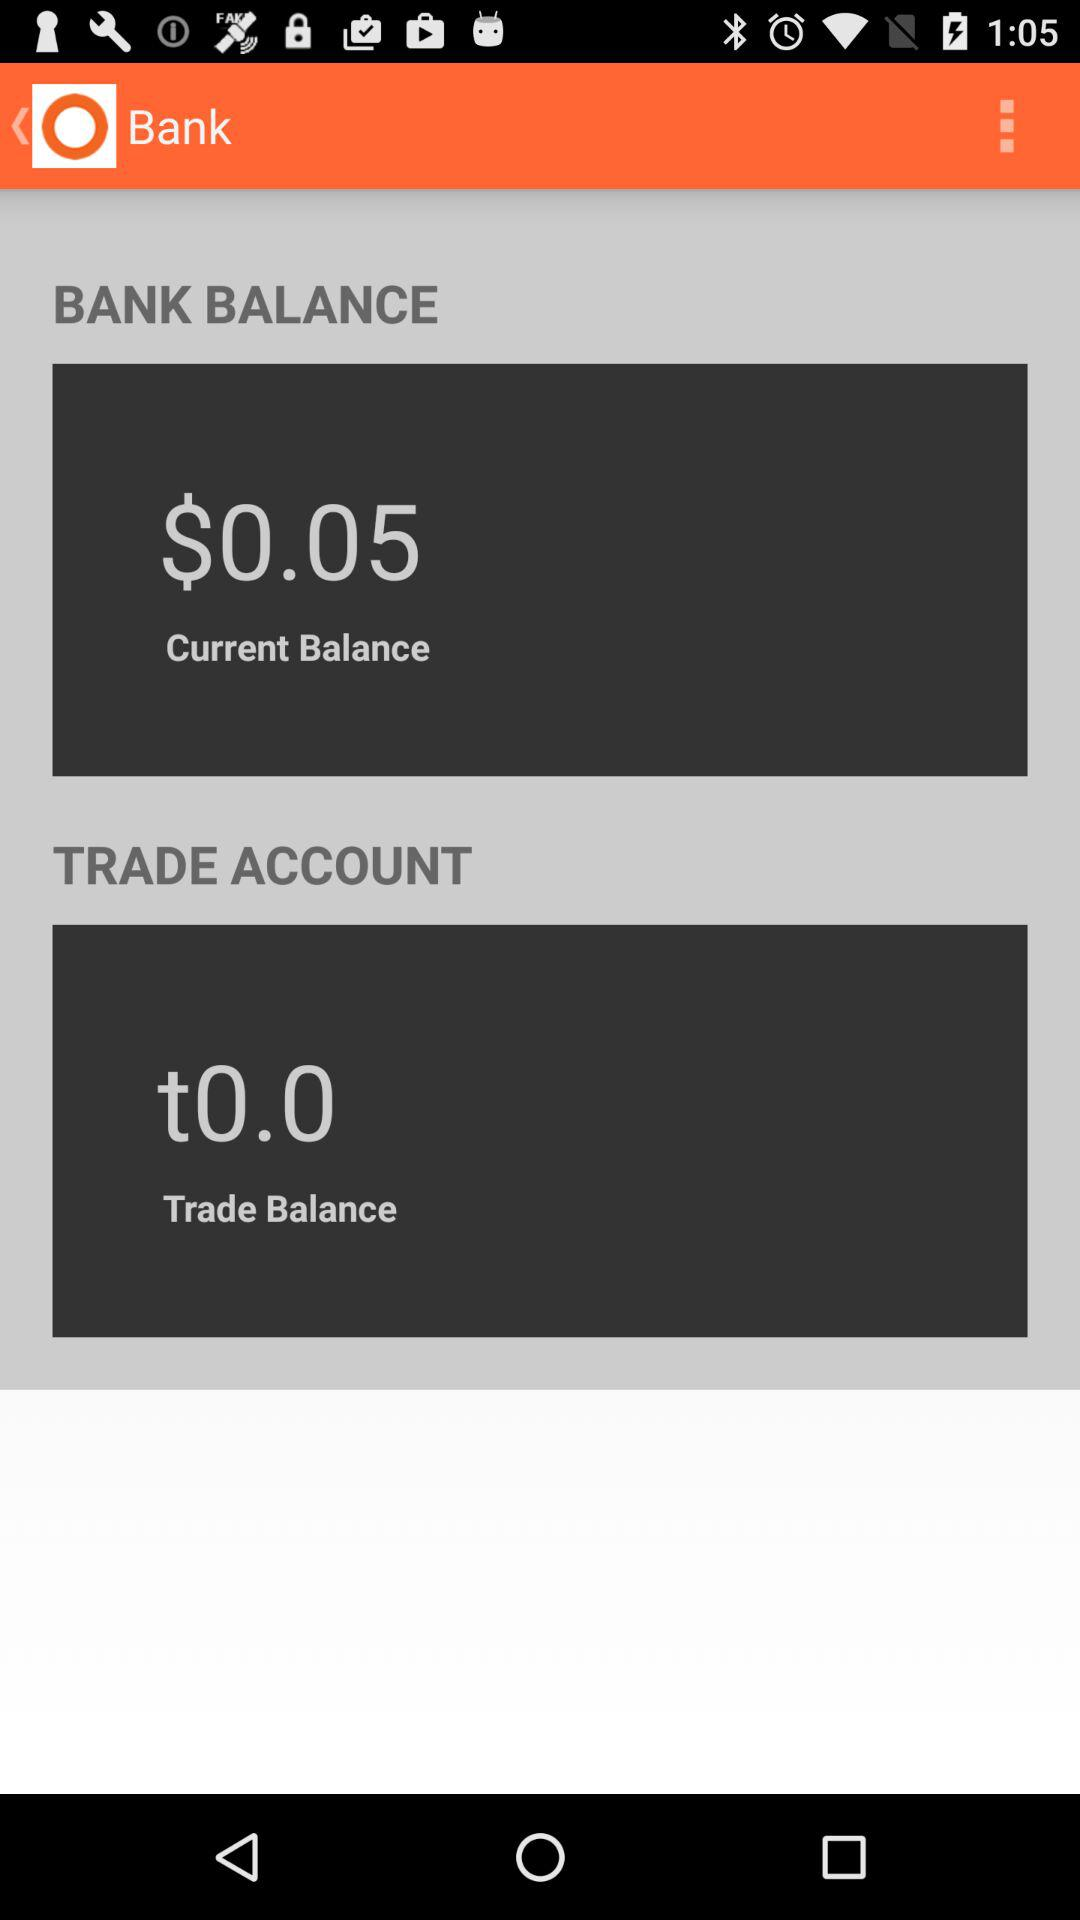What is the trade balance? The trade balance is 0. 